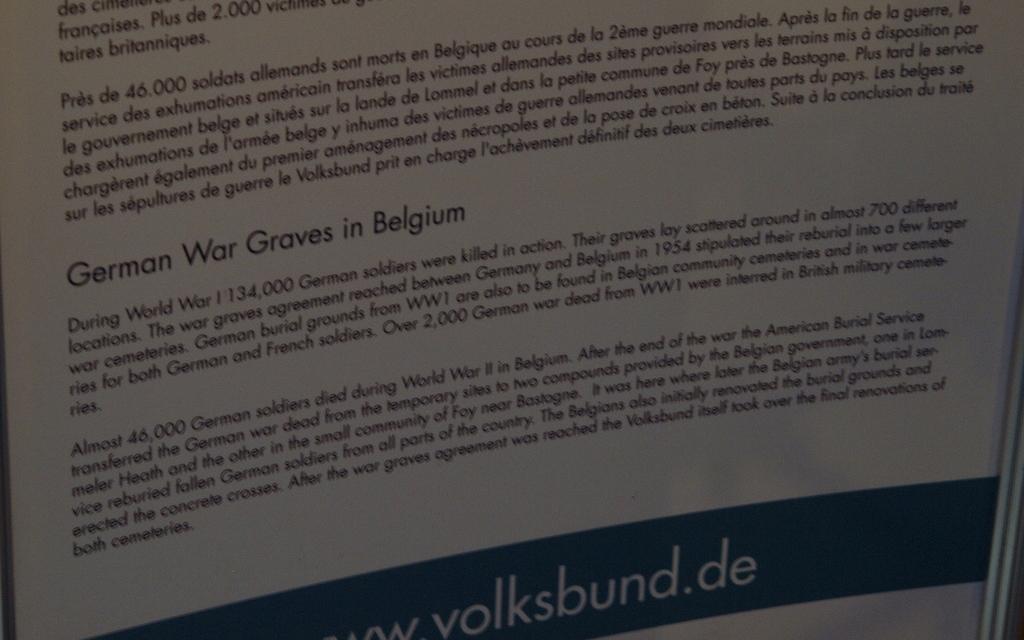What country has a lot of german graves from a war?
Ensure brevity in your answer.  Belgium. What does the paragraph displayed talk about?
Offer a very short reply. German war graves in belgium. 